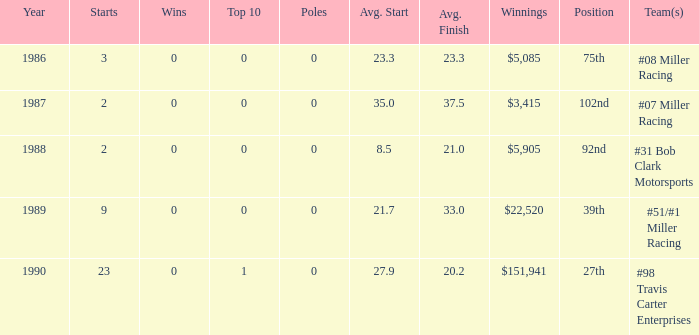3? 1.0. 